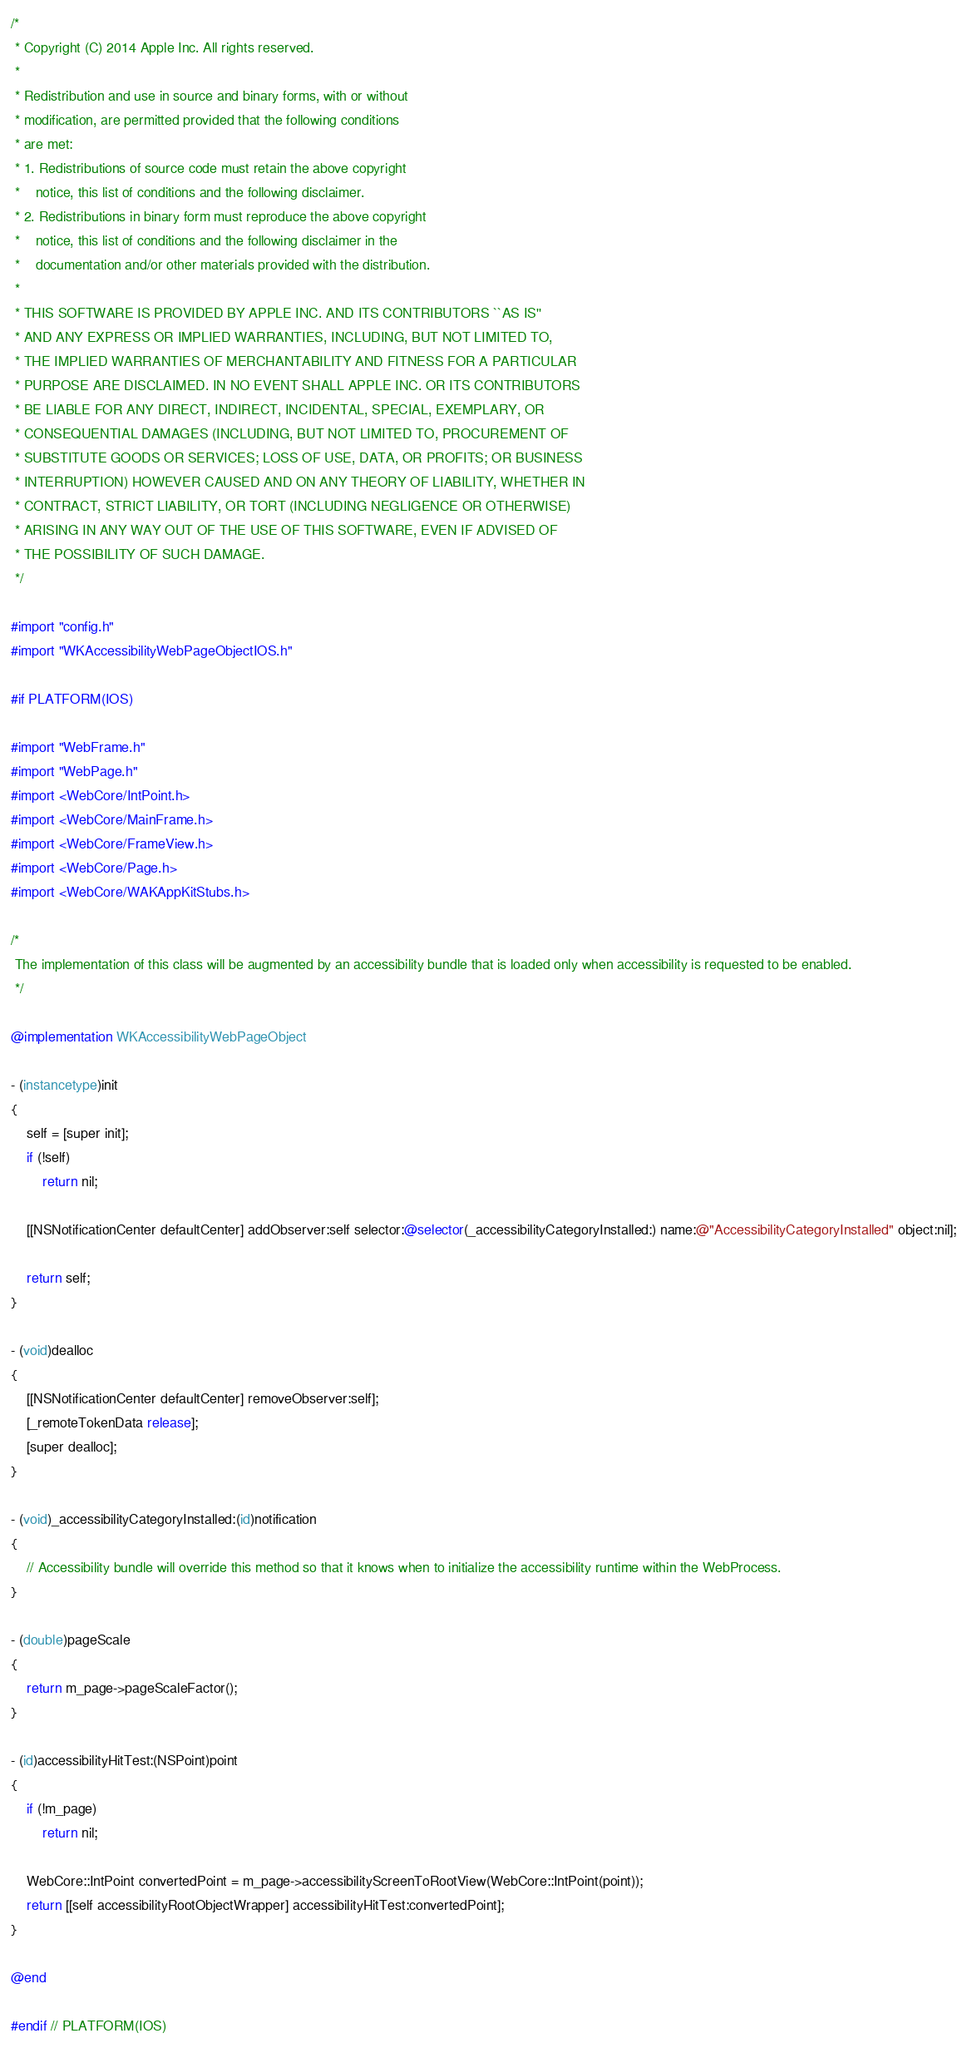Convert code to text. <code><loc_0><loc_0><loc_500><loc_500><_ObjectiveC_>/*
 * Copyright (C) 2014 Apple Inc. All rights reserved.
 *
 * Redistribution and use in source and binary forms, with or without
 * modification, are permitted provided that the following conditions
 * are met:
 * 1. Redistributions of source code must retain the above copyright
 *    notice, this list of conditions and the following disclaimer.
 * 2. Redistributions in binary form must reproduce the above copyright
 *    notice, this list of conditions and the following disclaimer in the
 *    documentation and/or other materials provided with the distribution.
 *
 * THIS SOFTWARE IS PROVIDED BY APPLE INC. AND ITS CONTRIBUTORS ``AS IS''
 * AND ANY EXPRESS OR IMPLIED WARRANTIES, INCLUDING, BUT NOT LIMITED TO,
 * THE IMPLIED WARRANTIES OF MERCHANTABILITY AND FITNESS FOR A PARTICULAR
 * PURPOSE ARE DISCLAIMED. IN NO EVENT SHALL APPLE INC. OR ITS CONTRIBUTORS
 * BE LIABLE FOR ANY DIRECT, INDIRECT, INCIDENTAL, SPECIAL, EXEMPLARY, OR
 * CONSEQUENTIAL DAMAGES (INCLUDING, BUT NOT LIMITED TO, PROCUREMENT OF
 * SUBSTITUTE GOODS OR SERVICES; LOSS OF USE, DATA, OR PROFITS; OR BUSINESS
 * INTERRUPTION) HOWEVER CAUSED AND ON ANY THEORY OF LIABILITY, WHETHER IN
 * CONTRACT, STRICT LIABILITY, OR TORT (INCLUDING NEGLIGENCE OR OTHERWISE)
 * ARISING IN ANY WAY OUT OF THE USE OF THIS SOFTWARE, EVEN IF ADVISED OF
 * THE POSSIBILITY OF SUCH DAMAGE.
 */

#import "config.h"
#import "WKAccessibilityWebPageObjectIOS.h"

#if PLATFORM(IOS)

#import "WebFrame.h"
#import "WebPage.h"
#import <WebCore/IntPoint.h>
#import <WebCore/MainFrame.h>
#import <WebCore/FrameView.h>
#import <WebCore/Page.h>
#import <WebCore/WAKAppKitStubs.h>

/* 
 The implementation of this class will be augmented by an accessibility bundle that is loaded only when accessibility is requested to be enabled.
 */

@implementation WKAccessibilityWebPageObject

- (instancetype)init
{
    self = [super init];
    if (!self)
        return nil;
    
    [[NSNotificationCenter defaultCenter] addObserver:self selector:@selector(_accessibilityCategoryInstalled:) name:@"AccessibilityCategoryInstalled" object:nil];

    return self;
}

- (void)dealloc
{
    [[NSNotificationCenter defaultCenter] removeObserver:self];
    [_remoteTokenData release];
    [super dealloc];
}

- (void)_accessibilityCategoryInstalled:(id)notification
{
    // Accessibility bundle will override this method so that it knows when to initialize the accessibility runtime within the WebProcess.
}

- (double)pageScale
{
    return m_page->pageScaleFactor();
}

- (id)accessibilityHitTest:(NSPoint)point
{
    if (!m_page)
        return nil;
    
    WebCore::IntPoint convertedPoint = m_page->accessibilityScreenToRootView(WebCore::IntPoint(point));
    return [[self accessibilityRootObjectWrapper] accessibilityHitTest:convertedPoint];
}

@end

#endif // PLATFORM(IOS)

</code> 